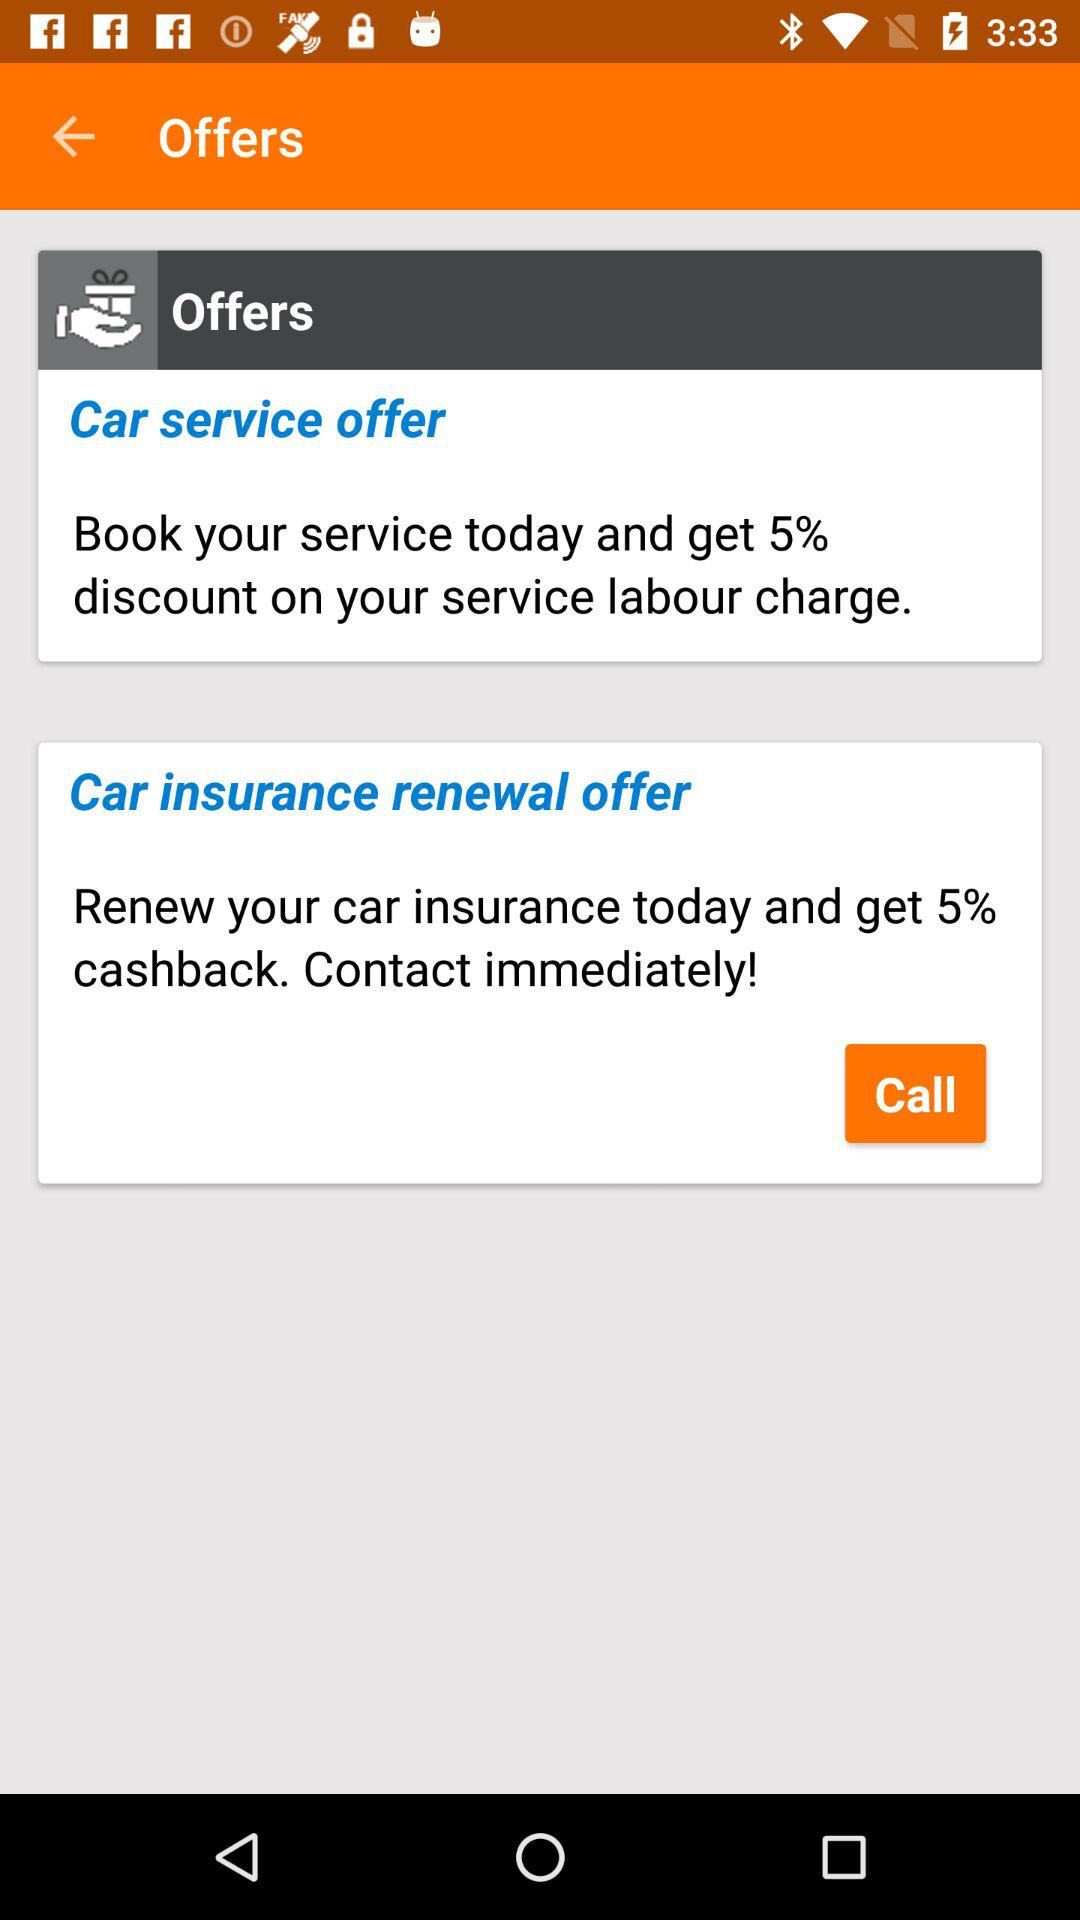How much discount is available on labour charges for car service? The discount available on labour charges for car service is 5%. 